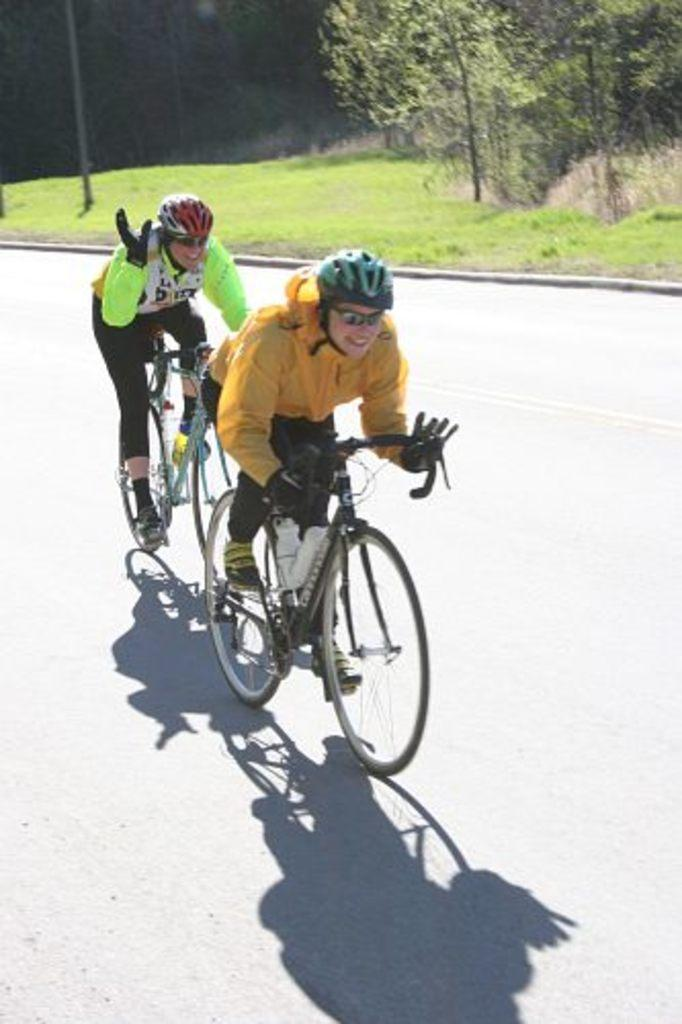How many people are in the image? There are two persons in the image. What are the two persons doing in the image? The two persons are riding a bicycle. Where is the bicycle located? The bicycle is on the road. What can be seen in the background of the image? There are trees visible in the background of the image. What type of eggnog is being served at the house in the image? There is no house or eggnog present in the image; it features two persons riding a bicycle on the road. Can you tell me how the hose is being used in the image? There is no hose present in the image. 